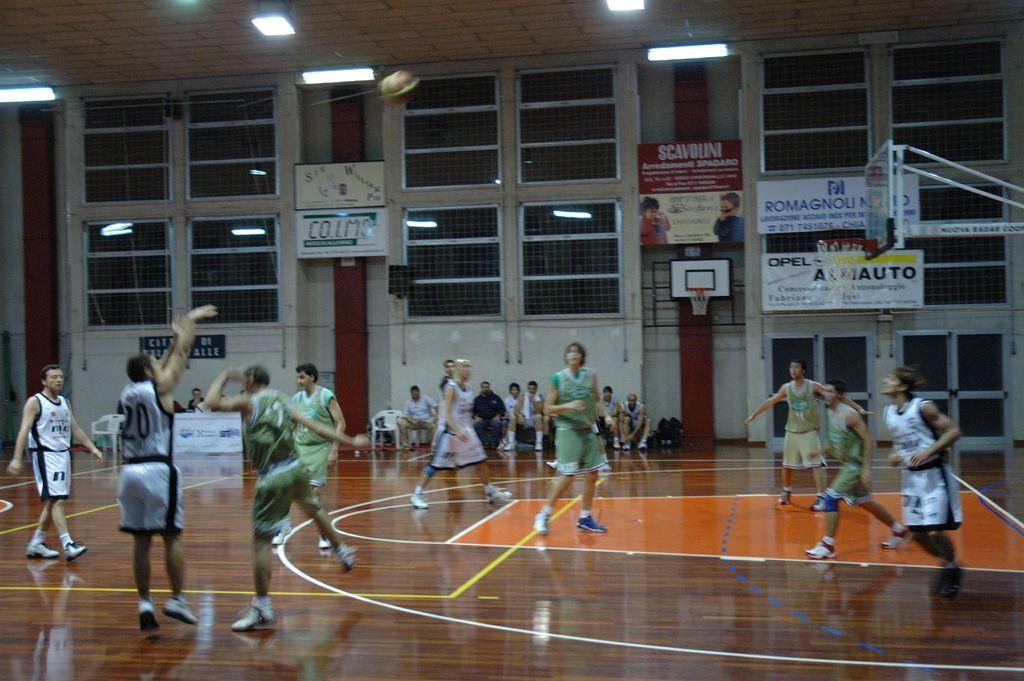Provide a one-sentence caption for the provided image. A basketball game is in progress on a court sponsored by Romagnoli and Opel, while number 20 shoots the ball. 